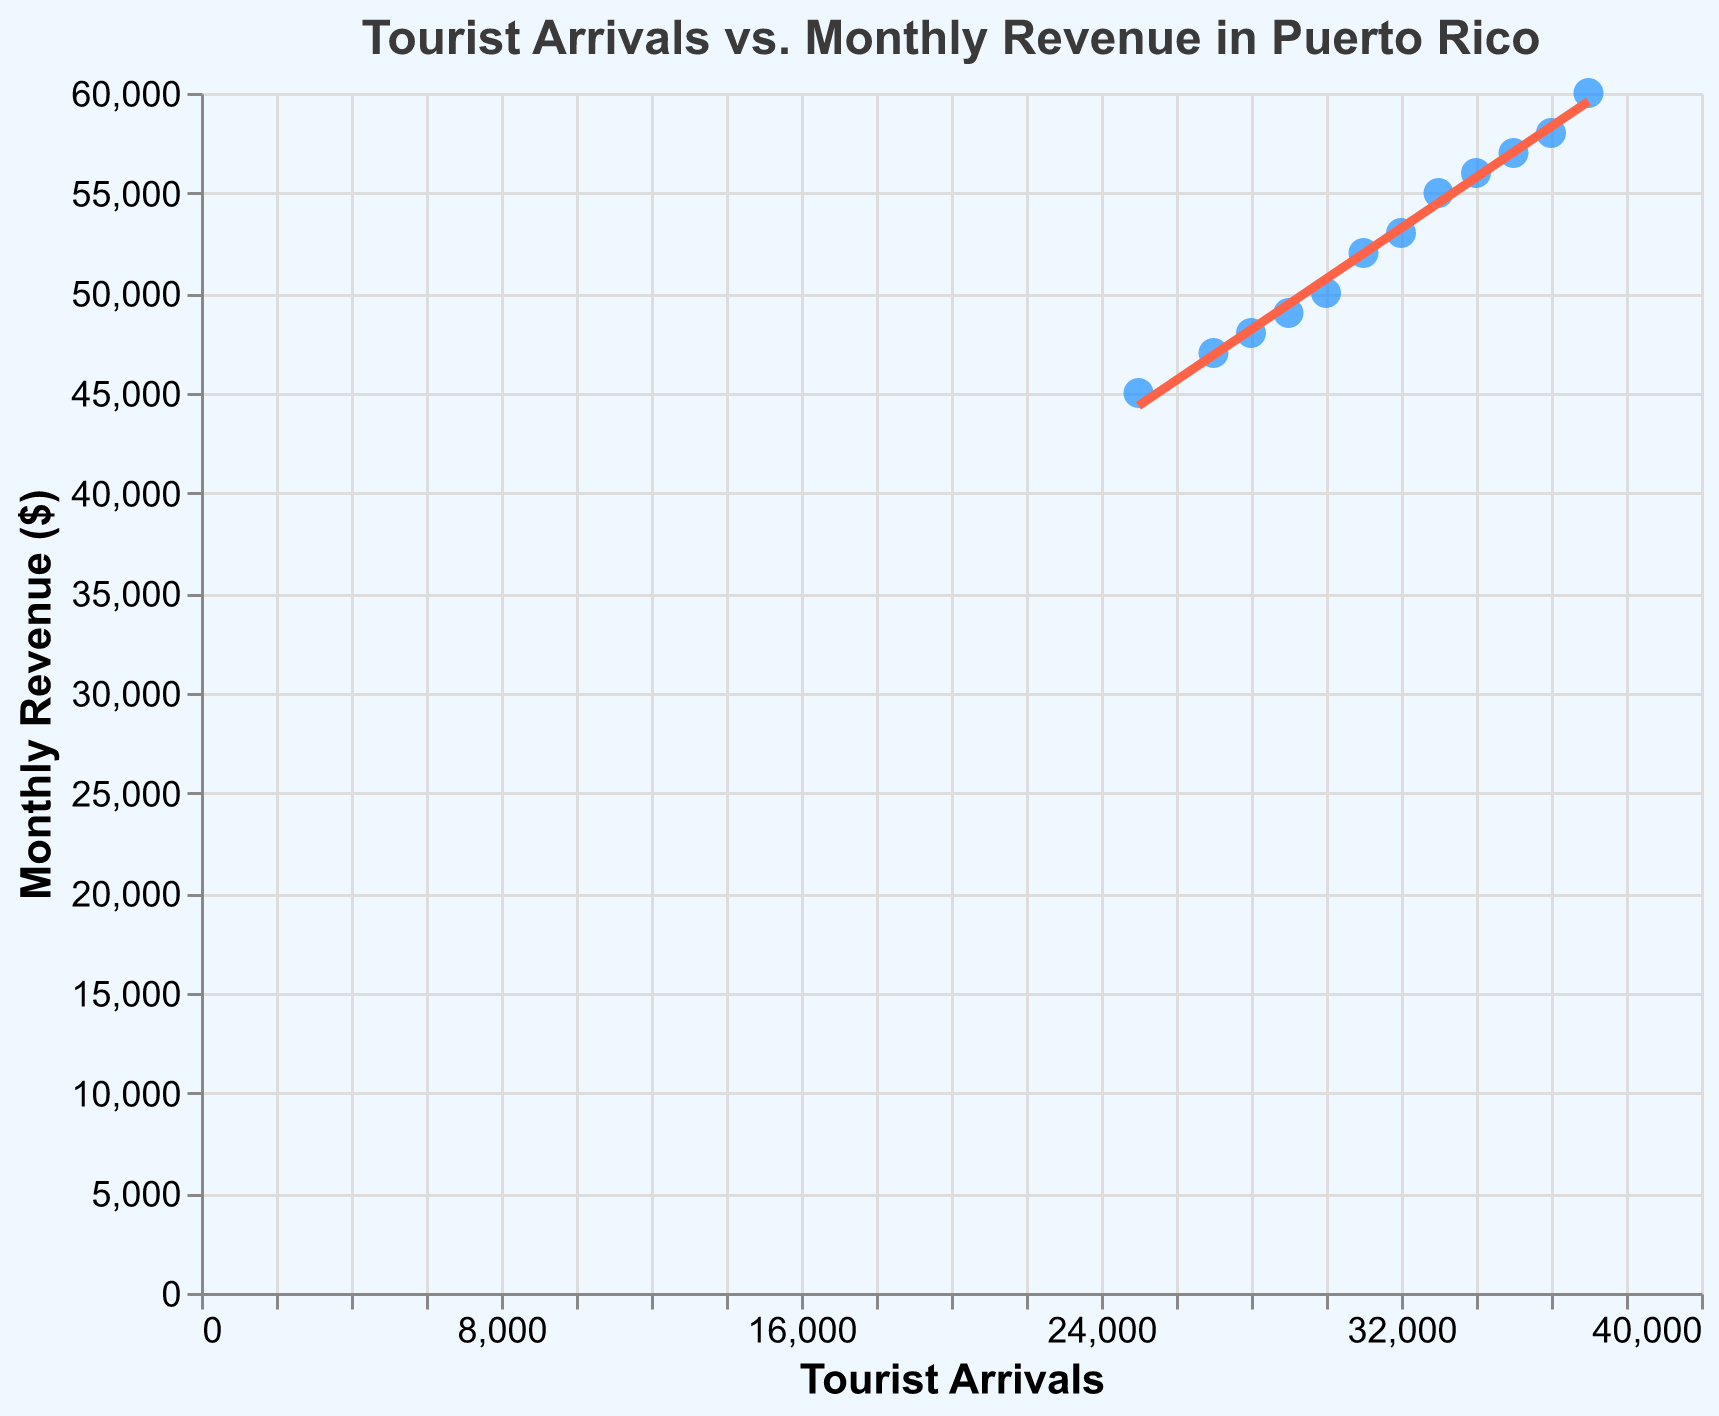What is the title of the figure? The title of the figure is usually found at the top of the plot. It describes what the figure is about.
Answer: Tourist Arrivals vs. Monthly Revenue in Puerto Rico How many data points are plotted in the figure? Counting each point on the scatter plot gives the number of data points. By referring to the provided data, there are 12 months, hence 12 points.
Answer: 12 What is the trend line's color and how many data points does it represent? The trend line is generally determined by regression and represents all data points in the scatter plot. According to the code, the trend line is colored "#ff6347", which is coral. There are 12 data points.
Answer: Coral, 12 Which month had the highest tourist arrivals, and what was the monthly revenue for that month? By looking at the data points and checking the tooltips, December 2023 had the highest tourist arrivals of 37,000, with the corresponding monthly revenue of $60,000.
Answer: December 2023, $60,000 What is the relationship between Tourist Arrivals and Monthly Revenue as shown by the trend line? The trend line, which shows a regression relationship, indicates that as tourist arrivals increase, the monthly revenue also increases. This is seen from the general upward slope of the trend line.
Answer: Positive relationship What is the revenue difference between the month with the highest and the lowest tourist arrivals? The month with the highest tourist arrivals is December 2023 (37,000 arrivals and $60,000 revenue), and the month with the lowest is January 2023 (25,000 arrivals and $45,000 revenue). The revenue difference is $60,000 - $45,000.
Answer: $15,000 What was the monthly revenue in March 2023, and how does it compare to July 2023? Refer to the tooltip for March 2023, which shows a revenue of $50,000. For July 2023, the revenue is $57,000. The revenue in March 2023 is $7,000 less than in July 2023.
Answer: $50,000, $7,000 less Which months had tourist arrivals between 30,000 and 35,000, and what were their corresponding revenues? By checking the data, the months with arrivals between 30,000 and 35,000 are March, April, May, June, August, and September. Their corresponding revenues are $50,000, $48,000, $49,000, $53,000, $56,000, and $55,000 respectively.
Answer: March, April, May, June, August, September; $50,000, $48,000, $49,000, $53,000, $56,000, $55,000 respectively What is the average monthly revenue for the entire year? Sum up all the monthly revenues and divide by the number of months. The sum is $45,000 + $47,000 + $50,000 + $48,000 + $49,000 + $53,000 + $57,000 + $56,000 + $55,000 + $52,000 + $58,000 + $60,000 = $630,000. Divide by 12 months.
Answer: $52,500 Do tourist arrivals and monthly revenue appear to have an outlier, and which month is it? By observing the scatter plot, it doesn't appear there are any significant outliers since all points seem to follow the trend line closely.
Answer: No, none 